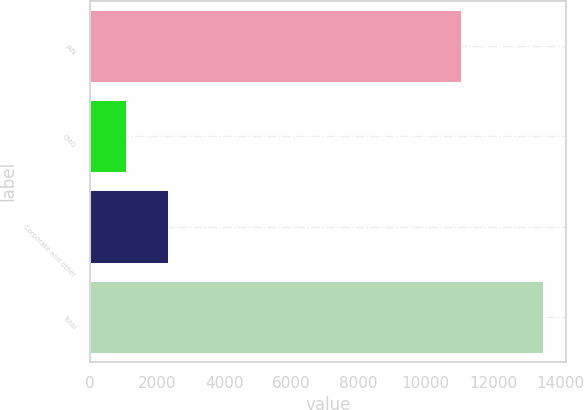Convert chart. <chart><loc_0><loc_0><loc_500><loc_500><bar_chart><fcel>IAN<fcel>CMG<fcel>Corporate and other<fcel>Total<nl><fcel>11035.3<fcel>1073.1<fcel>2315.18<fcel>13493.9<nl></chart> 